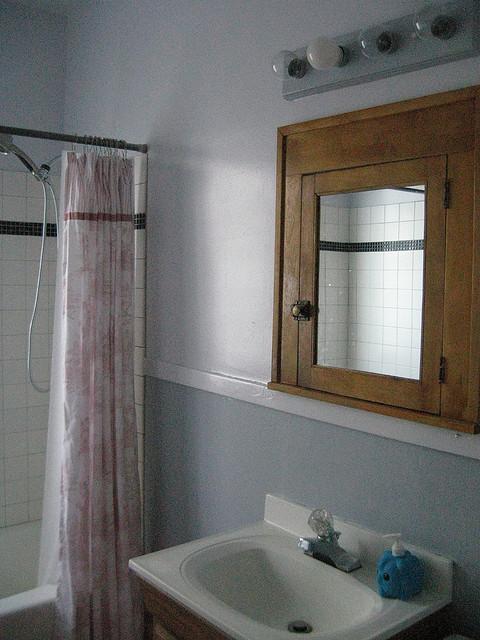What color is the tile trim in the shower?
Concise answer only. Black. What room is this?
Write a very short answer. Bathroom. Do all of the light bulbs match?
Concise answer only. No. 